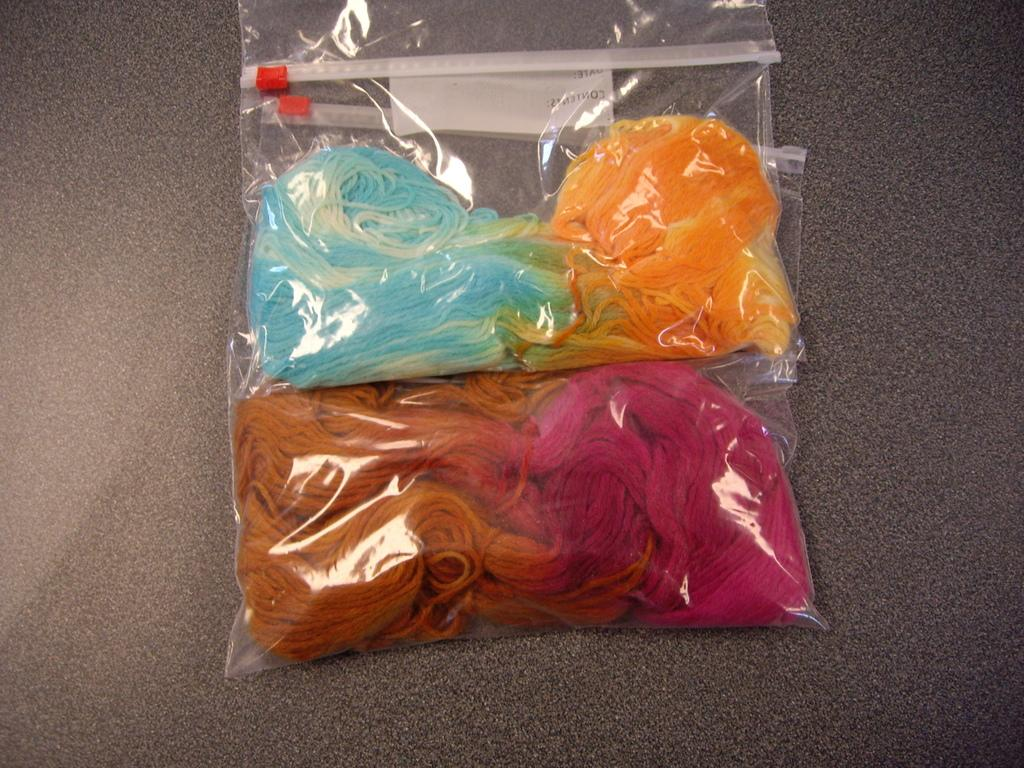What are the objects in the image covered with? The objects in the image are covered with polythene covers. Can you describe the appearance of the polythene covers? The polythene covers have different colors. What type of home can be seen in the background of the image? There is no home visible in the image; it only shows objects covered in polythene with different colors. 